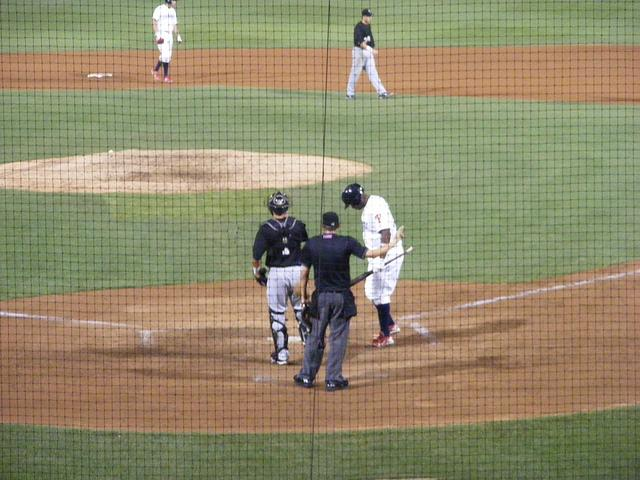Who is wearing the most gear?

Choices:
A) police officer
B) fire fighter
C) clown
D) catcher catcher 